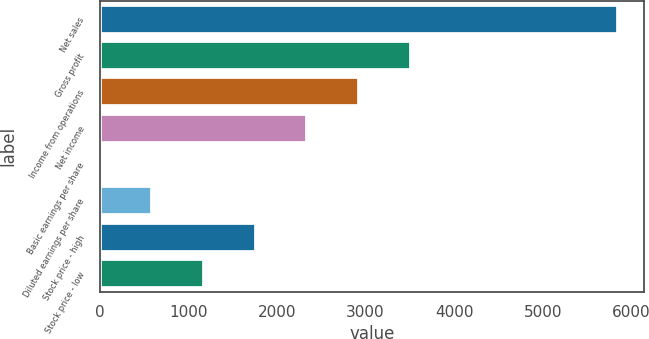Convert chart. <chart><loc_0><loc_0><loc_500><loc_500><bar_chart><fcel>Net sales<fcel>Gross profit<fcel>Income from operations<fcel>Net income<fcel>Basic earnings per share<fcel>Diluted earnings per share<fcel>Stock price - high<fcel>Stock price - low<nl><fcel>5852.6<fcel>3513.15<fcel>2928.29<fcel>2343.43<fcel>3.99<fcel>588.85<fcel>1758.57<fcel>1173.71<nl></chart> 